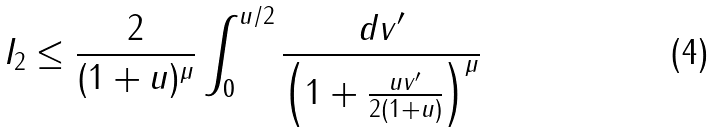Convert formula to latex. <formula><loc_0><loc_0><loc_500><loc_500>I _ { 2 } & \leq \frac { 2 } { ( 1 + u ) ^ { \mu } } \int _ { 0 } ^ { u / 2 } \frac { d v ^ { \prime } } { \left ( 1 + \frac { u v ^ { \prime } } { 2 ( 1 + u ) } \right ) ^ { \mu } }</formula> 